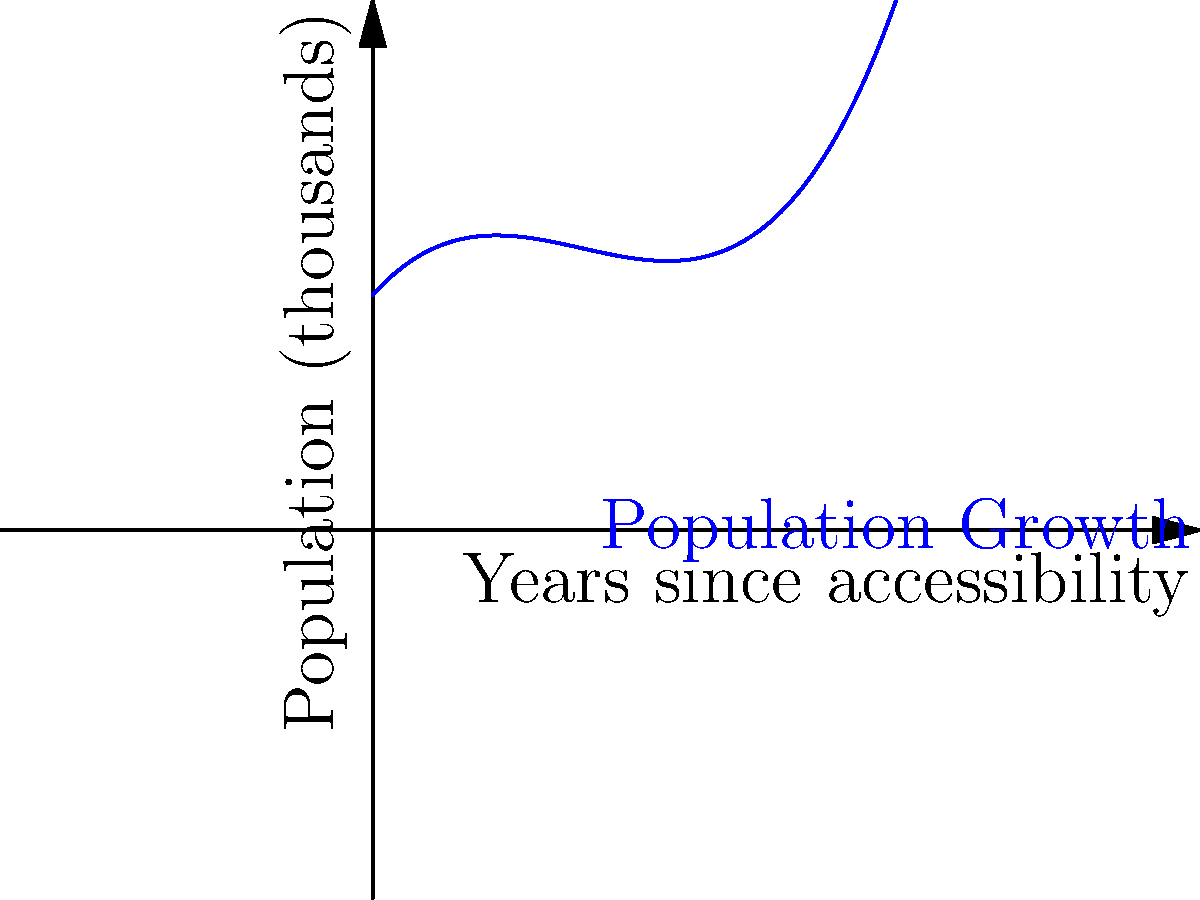The graph shows the population growth in a newly accessible neighborhood over 5 years, modeled by a cubic polynomial. If the trend continues, approximately how many years after becoming accessible will the neighborhood's population reach its minimum before starting to grow again? To find the minimum point, we need to follow these steps:

1. The general form of a cubic polynomial is $f(x) = ax^3 + bx^2 + cx + d$

2. The derivative of this function is $f'(x) = 3ax^2 + 2bx + c$

3. To find the minimum, we set $f'(x) = 0$ and solve for x:

   $3ax^2 + 2bx + c = 0$

4. This is a quadratic equation. The smaller solution will be the minimum point.

5. From the graph, we can estimate that the minimum occurs between 1 and 2 years.

6. The exact solution would require knowing the specific coefficients, but we can approximate it to be around 1.5 years based on the graph.

7. As a real estate agent, you should be aware that this minimum point represents the time when the neighborhood starts to become more attractive to potential buyers, leading to population growth.
Answer: Approximately 1.5 years 